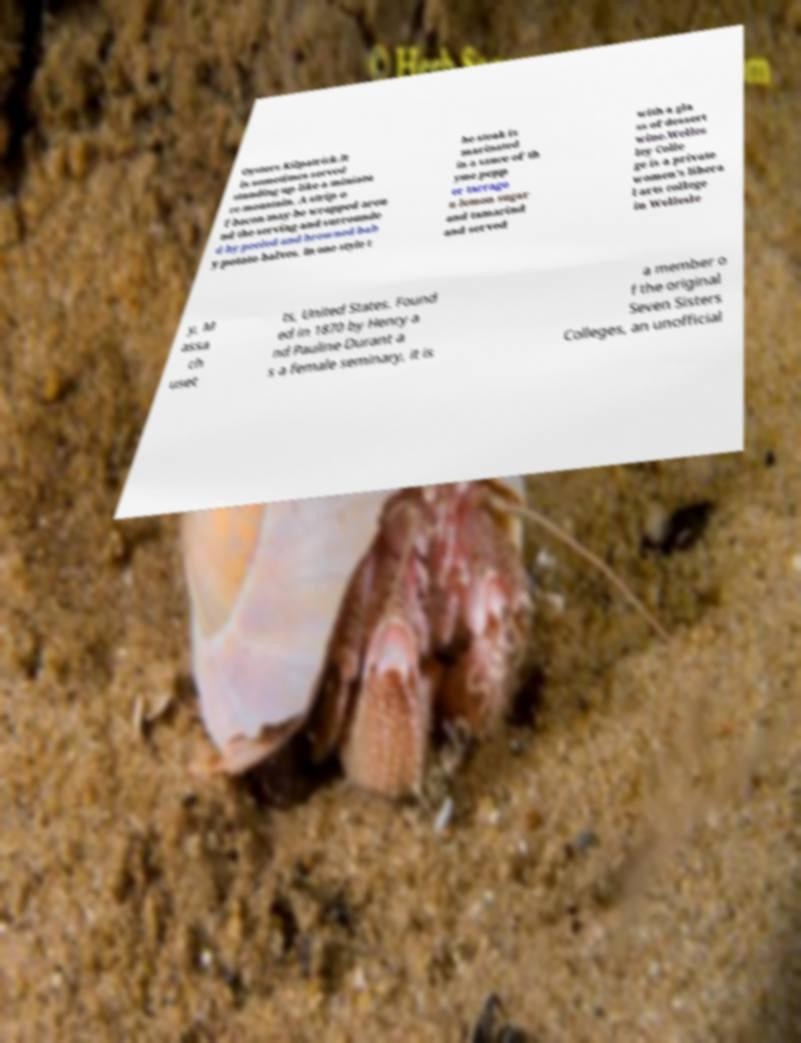I need the written content from this picture converted into text. Can you do that? Oysters Kilpatrick.It is sometimes served standing up like a miniatu re mountain. A strip o f bacon may be wrapped arou nd the serving and surrounde d by peeled and browned bab y potato halves. In one style t he steak is marinated in a sauce of th yme pepp er tarrago n lemon sugar and tamarind and served with a gla ss of dessert wine.Welles ley Colle ge is a private women's libera l arts college in Wellesle y, M assa ch uset ts, United States. Found ed in 1870 by Henry a nd Pauline Durant a s a female seminary, it is a member o f the original Seven Sisters Colleges, an unofficial 